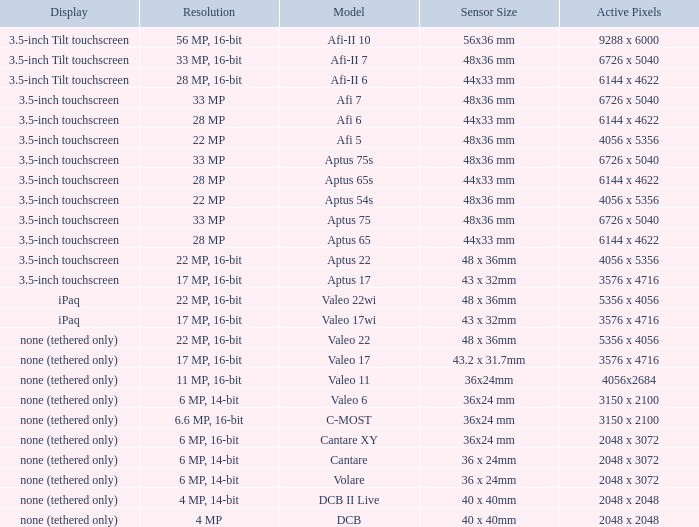What is the resolution of the camera that has 6726 x 5040 pixels and a model of afi 7? 33 MP. 